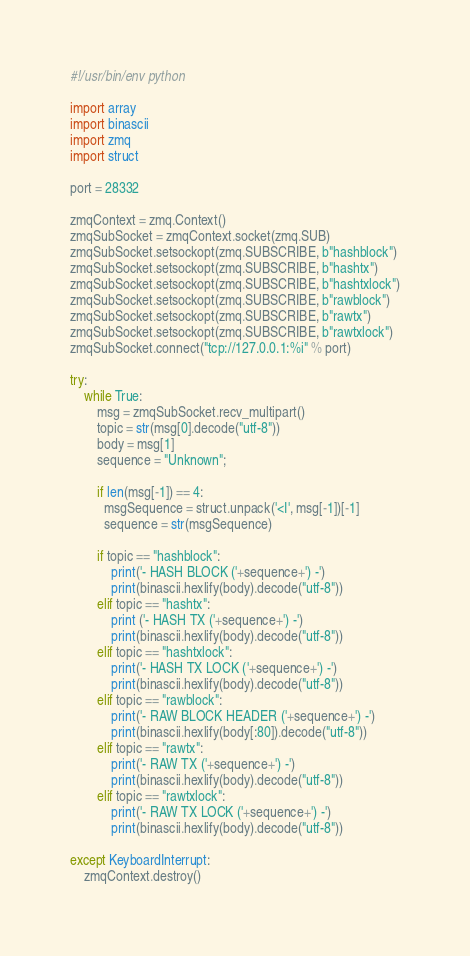Convert code to text. <code><loc_0><loc_0><loc_500><loc_500><_Python_>#!/usr/bin/env python

import array
import binascii
import zmq
import struct

port = 28332

zmqContext = zmq.Context()
zmqSubSocket = zmqContext.socket(zmq.SUB)
zmqSubSocket.setsockopt(zmq.SUBSCRIBE, b"hashblock")
zmqSubSocket.setsockopt(zmq.SUBSCRIBE, b"hashtx")
zmqSubSocket.setsockopt(zmq.SUBSCRIBE, b"hashtxlock")
zmqSubSocket.setsockopt(zmq.SUBSCRIBE, b"rawblock")
zmqSubSocket.setsockopt(zmq.SUBSCRIBE, b"rawtx")
zmqSubSocket.setsockopt(zmq.SUBSCRIBE, b"rawtxlock")
zmqSubSocket.connect("tcp://127.0.0.1:%i" % port)

try:
    while True:
        msg = zmqSubSocket.recv_multipart()
        topic = str(msg[0].decode("utf-8"))
        body = msg[1]
        sequence = "Unknown";

        if len(msg[-1]) == 4:
          msgSequence = struct.unpack('<I', msg[-1])[-1]
          sequence = str(msgSequence)

        if topic == "hashblock":
            print('- HASH BLOCK ('+sequence+') -')
            print(binascii.hexlify(body).decode("utf-8"))
        elif topic == "hashtx":
            print ('- HASH TX ('+sequence+') -')
            print(binascii.hexlify(body).decode("utf-8"))
        elif topic == "hashtxlock":
            print('- HASH TX LOCK ('+sequence+') -')
            print(binascii.hexlify(body).decode("utf-8"))
        elif topic == "rawblock":
            print('- RAW BLOCK HEADER ('+sequence+') -')
            print(binascii.hexlify(body[:80]).decode("utf-8"))
        elif topic == "rawtx":
            print('- RAW TX ('+sequence+') -')
            print(binascii.hexlify(body).decode("utf-8"))
        elif topic == "rawtxlock":
            print('- RAW TX LOCK ('+sequence+') -')
            print(binascii.hexlify(body).decode("utf-8"))

except KeyboardInterrupt:
    zmqContext.destroy()
</code> 